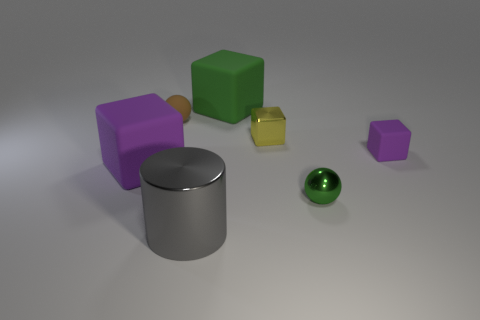Add 1 spheres. How many objects exist? 8 Subtract all rubber cubes. How many cubes are left? 1 Subtract all blocks. How many objects are left? 3 Subtract all red blocks. Subtract all gray cylinders. How many blocks are left? 4 Subtract all purple blocks. How many red balls are left? 0 Subtract all large matte cubes. Subtract all tiny matte balls. How many objects are left? 4 Add 7 purple rubber objects. How many purple rubber objects are left? 9 Add 7 green shiny objects. How many green shiny objects exist? 8 Subtract all brown balls. How many balls are left? 1 Subtract 0 cyan cylinders. How many objects are left? 7 